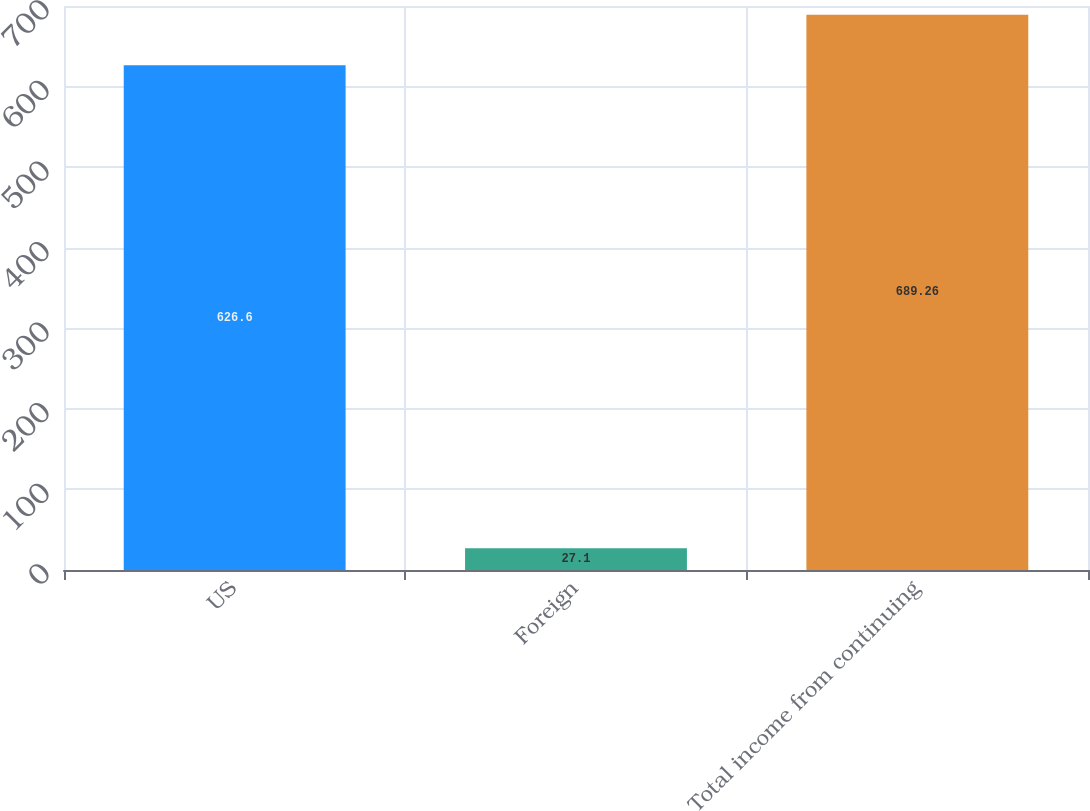Convert chart to OTSL. <chart><loc_0><loc_0><loc_500><loc_500><bar_chart><fcel>US<fcel>Foreign<fcel>Total income from continuing<nl><fcel>626.6<fcel>27.1<fcel>689.26<nl></chart> 